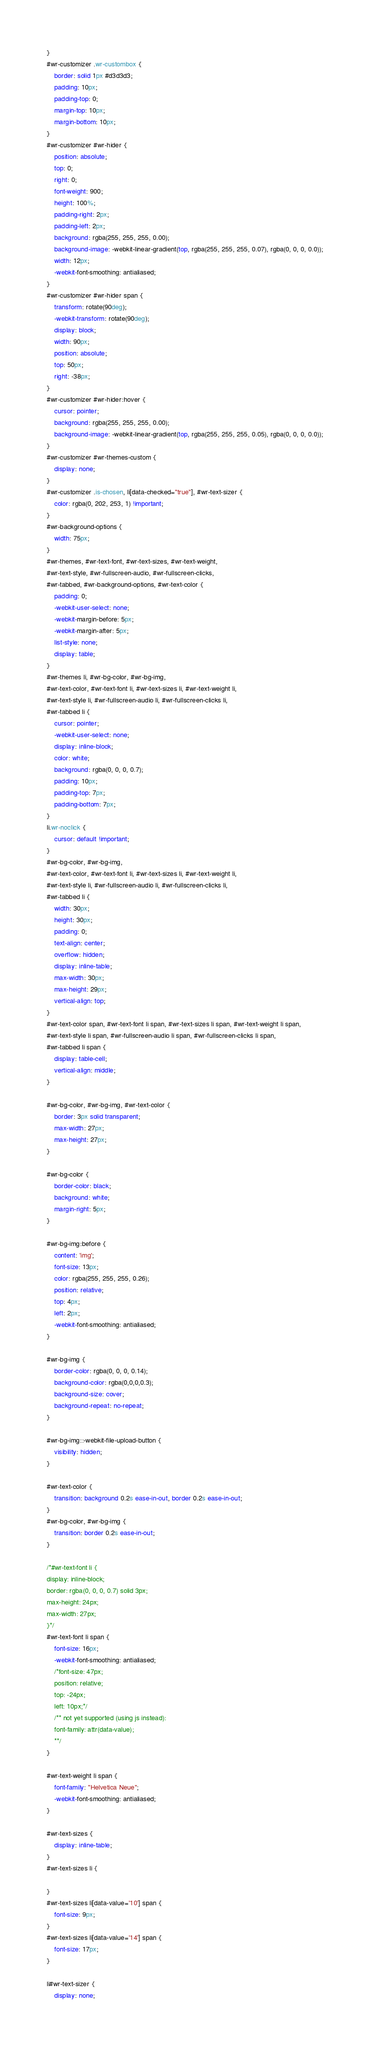<code> <loc_0><loc_0><loc_500><loc_500><_CSS_>}
#wr-customizer .wr-custombox {
    border: solid 1px #d3d3d3;
    padding: 10px;
    padding-top: 0;
    margin-top: 10px;
    margin-bottom: 10px;
}
#wr-customizer #wr-hider {
    position: absolute;
    top: 0;
    right: 0;
    font-weight: 900;
    height: 100%;
    padding-right: 2px;
    padding-left: 2px;
    background: rgba(255, 255, 255, 0.00);
    background-image: -webkit-linear-gradient(top, rgba(255, 255, 255, 0.07), rgba(0, 0, 0, 0.0));
    width: 12px;
    -webkit-font-smoothing: antialiased;
}
#wr-customizer #wr-hider span {
    transform: rotate(90deg);
    -webkit-transform: rotate(90deg);
    display: block;
    width: 90px;
    position: absolute;
    top: 50px;
    right: -38px;
}
#wr-customizer #wr-hider:hover {
    cursor: pointer;
    background: rgba(255, 255, 255, 0.00);
    background-image: -webkit-linear-gradient(top, rgba(255, 255, 255, 0.05), rgba(0, 0, 0, 0.0));
}
#wr-customizer #wr-themes-custom {
    display: none;
}
#wr-customizer .is-chosen, li[data-checked="true"], #wr-text-sizer {
    color: rgba(0, 202, 253, 1) !important;
}
#wr-background-options {
    width: 75px;
}
#wr-themes, #wr-text-font, #wr-text-sizes, #wr-text-weight,
#wr-text-style, #wr-fullscreen-audio, #wr-fullscreen-clicks,
#wr-tabbed, #wr-background-options, #wr-text-color {
    padding: 0;
    -webkit-user-select: none;
    -webkit-margin-before: 5px;
    -webkit-margin-after: 5px;
    list-style: none;
    display: table;
}
#wr-themes li, #wr-bg-color, #wr-bg-img, 
#wr-text-color, #wr-text-font li, #wr-text-sizes li, #wr-text-weight li,
#wr-text-style li, #wr-fullscreen-audio li, #wr-fullscreen-clicks li,
#wr-tabbed li {
    cursor: pointer;
    -webkit-user-select: none;
    display: inline-block;
    color: white;
    background: rgba(0, 0, 0, 0.7);
    padding: 10px;
    padding-top: 7px;
    padding-bottom: 7px;
}
li.wr-noclick {
    cursor: default !important;
}
#wr-bg-color, #wr-bg-img, 
#wr-text-color, #wr-text-font li, #wr-text-sizes li, #wr-text-weight li,
#wr-text-style li, #wr-fullscreen-audio li, #wr-fullscreen-clicks li,
#wr-tabbed li {
    width: 30px;
    height: 30px;
    padding: 0;
    text-align: center;
    overflow: hidden;
    display: inline-table;
    max-width: 30px;
    max-height: 29px;
    vertical-align: top;
}
#wr-text-color span, #wr-text-font li span, #wr-text-sizes li span, #wr-text-weight li span,
#wr-text-style li span, #wr-fullscreen-audio li span, #wr-fullscreen-clicks li span,
#wr-tabbed li span {
    display: table-cell;
    vertical-align: middle;
}

#wr-bg-color, #wr-bg-img, #wr-text-color {
    border: 3px solid transparent;
    max-width: 27px;
    max-height: 27px;
}

#wr-bg-color {
    border-color: black;
    background: white;
    margin-right: 5px;
}

#wr-bg-img:before {
    content: 'img';
    font-size: 13px;
    color: rgba(255, 255, 255, 0.26);
    position: relative;
    top: 4px;
    left: 2px;
    -webkit-font-smoothing: antialiased;
}

#wr-bg-img {
    border-color: rgba(0, 0, 0, 0.14);
    background-color: rgba(0,0,0,0.3);
    background-size: cover;
    background-repeat: no-repeat;
}

#wr-bg-img::-webkit-file-upload-button {
    visibility: hidden;
}

#wr-text-color {
    transition: background 0.2s ease-in-out, border 0.2s ease-in-out;
}
#wr-bg-color, #wr-bg-img {
    transition: border 0.2s ease-in-out;
}

/*#wr-text-font li {
display: inline-block;
border: rgba(0, 0, 0, 0.7) solid 3px;
max-height: 24px;
max-width: 27px;
}*/
#wr-text-font li span {
    font-size: 16px;
    -webkit-font-smoothing: antialiased;
    /*font-size: 47px;
    position: relative;
    top: -24px;
    left: 10px;*/
    /** not yet supported (using js instead):
    font-family: attr(data-value);
    **/
}

#wr-text-weight li span {
    font-family: "Helvetica Neue";
    -webkit-font-smoothing: antialiased;
}

#wr-text-sizes {
    display: inline-table;
}
#wr-text-sizes li {
    
}
#wr-text-sizes li[data-value='10'] span {
    font-size: 9px;
}
#wr-text-sizes li[data-value='14'] span {
    font-size: 17px;
}

li#wr-text-sizer {
    display: none;</code> 